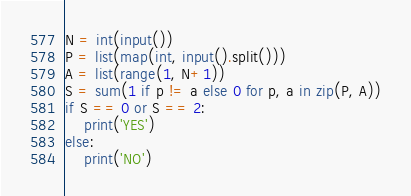Convert code to text. <code><loc_0><loc_0><loc_500><loc_500><_Python_>N = int(input())
P = list(map(int, input().split()))
A = list(range(1, N+1))
S = sum(1 if p != a else 0 for p, a in zip(P, A))
if S == 0 or S == 2:
    print('YES')
else:
    print('NO')</code> 